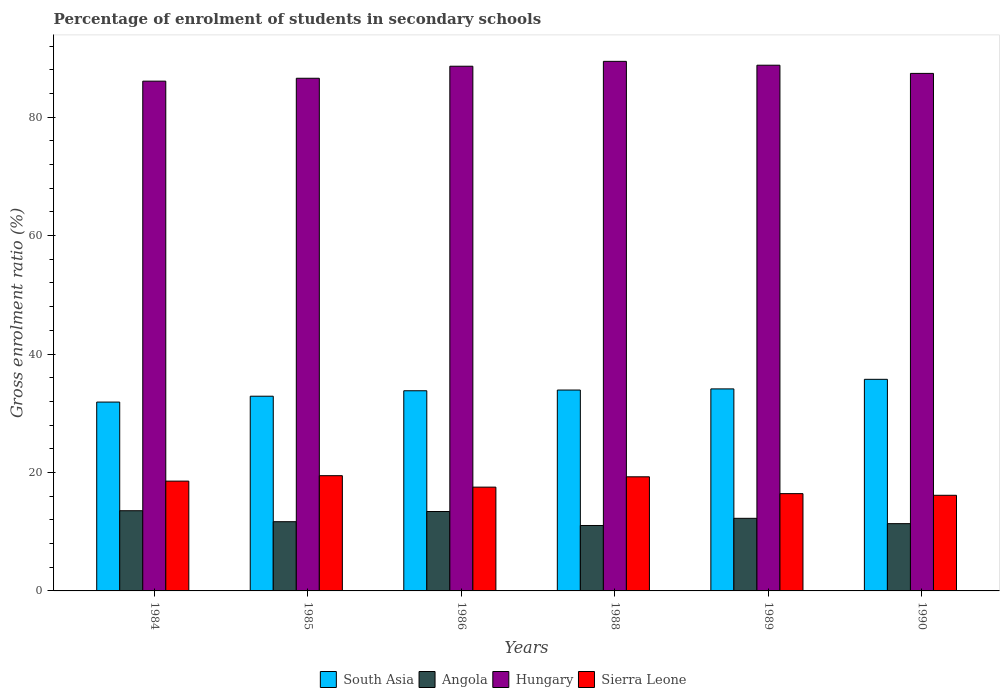How many groups of bars are there?
Your answer should be compact. 6. Are the number of bars per tick equal to the number of legend labels?
Your response must be concise. Yes. Are the number of bars on each tick of the X-axis equal?
Your response must be concise. Yes. How many bars are there on the 3rd tick from the right?
Your response must be concise. 4. What is the label of the 6th group of bars from the left?
Your response must be concise. 1990. In how many cases, is the number of bars for a given year not equal to the number of legend labels?
Offer a very short reply. 0. What is the percentage of students enrolled in secondary schools in Hungary in 1988?
Make the answer very short. 89.41. Across all years, what is the maximum percentage of students enrolled in secondary schools in Sierra Leone?
Make the answer very short. 19.46. Across all years, what is the minimum percentage of students enrolled in secondary schools in Hungary?
Provide a succinct answer. 86.07. What is the total percentage of students enrolled in secondary schools in Sierra Leone in the graph?
Your answer should be compact. 107.36. What is the difference between the percentage of students enrolled in secondary schools in South Asia in 1985 and that in 1989?
Keep it short and to the point. -1.23. What is the difference between the percentage of students enrolled in secondary schools in Sierra Leone in 1989 and the percentage of students enrolled in secondary schools in Hungary in 1990?
Make the answer very short. -70.95. What is the average percentage of students enrolled in secondary schools in Hungary per year?
Your response must be concise. 87.79. In the year 1986, what is the difference between the percentage of students enrolled in secondary schools in Sierra Leone and percentage of students enrolled in secondary schools in Hungary?
Give a very brief answer. -71.06. What is the ratio of the percentage of students enrolled in secondary schools in Hungary in 1984 to that in 1988?
Make the answer very short. 0.96. Is the difference between the percentage of students enrolled in secondary schools in Sierra Leone in 1988 and 1990 greater than the difference between the percentage of students enrolled in secondary schools in Hungary in 1988 and 1990?
Ensure brevity in your answer.  Yes. What is the difference between the highest and the second highest percentage of students enrolled in secondary schools in Hungary?
Your answer should be very brief. 0.65. What is the difference between the highest and the lowest percentage of students enrolled in secondary schools in Angola?
Offer a terse response. 2.49. In how many years, is the percentage of students enrolled in secondary schools in Angola greater than the average percentage of students enrolled in secondary schools in Angola taken over all years?
Offer a very short reply. 3. Is it the case that in every year, the sum of the percentage of students enrolled in secondary schools in Hungary and percentage of students enrolled in secondary schools in Angola is greater than the sum of percentage of students enrolled in secondary schools in Sierra Leone and percentage of students enrolled in secondary schools in South Asia?
Provide a succinct answer. No. What does the 4th bar from the left in 1986 represents?
Offer a very short reply. Sierra Leone. What does the 2nd bar from the right in 1989 represents?
Offer a very short reply. Hungary. How many years are there in the graph?
Your response must be concise. 6. Does the graph contain any zero values?
Your answer should be very brief. No. Does the graph contain grids?
Make the answer very short. No. Where does the legend appear in the graph?
Your response must be concise. Bottom center. How many legend labels are there?
Give a very brief answer. 4. What is the title of the graph?
Offer a terse response. Percentage of enrolment of students in secondary schools. Does "Timor-Leste" appear as one of the legend labels in the graph?
Keep it short and to the point. No. What is the label or title of the X-axis?
Provide a succinct answer. Years. What is the label or title of the Y-axis?
Make the answer very short. Gross enrolment ratio (%). What is the Gross enrolment ratio (%) in South Asia in 1984?
Provide a succinct answer. 31.88. What is the Gross enrolment ratio (%) of Angola in 1984?
Give a very brief answer. 13.54. What is the Gross enrolment ratio (%) of Hungary in 1984?
Provide a succinct answer. 86.07. What is the Gross enrolment ratio (%) in Sierra Leone in 1984?
Provide a succinct answer. 18.54. What is the Gross enrolment ratio (%) of South Asia in 1985?
Ensure brevity in your answer.  32.87. What is the Gross enrolment ratio (%) of Angola in 1985?
Provide a succinct answer. 11.69. What is the Gross enrolment ratio (%) in Hungary in 1985?
Offer a very short reply. 86.55. What is the Gross enrolment ratio (%) in Sierra Leone in 1985?
Keep it short and to the point. 19.46. What is the Gross enrolment ratio (%) in South Asia in 1986?
Your answer should be very brief. 33.8. What is the Gross enrolment ratio (%) in Angola in 1986?
Make the answer very short. 13.41. What is the Gross enrolment ratio (%) in Hungary in 1986?
Your response must be concise. 88.59. What is the Gross enrolment ratio (%) in Sierra Leone in 1986?
Provide a short and direct response. 17.52. What is the Gross enrolment ratio (%) of South Asia in 1988?
Your response must be concise. 33.92. What is the Gross enrolment ratio (%) in Angola in 1988?
Ensure brevity in your answer.  11.05. What is the Gross enrolment ratio (%) of Hungary in 1988?
Ensure brevity in your answer.  89.41. What is the Gross enrolment ratio (%) of Sierra Leone in 1988?
Ensure brevity in your answer.  19.27. What is the Gross enrolment ratio (%) in South Asia in 1989?
Provide a short and direct response. 34.11. What is the Gross enrolment ratio (%) of Angola in 1989?
Provide a succinct answer. 12.26. What is the Gross enrolment ratio (%) in Hungary in 1989?
Ensure brevity in your answer.  88.76. What is the Gross enrolment ratio (%) of Sierra Leone in 1989?
Give a very brief answer. 16.43. What is the Gross enrolment ratio (%) in South Asia in 1990?
Make the answer very short. 35.73. What is the Gross enrolment ratio (%) of Angola in 1990?
Your answer should be compact. 11.36. What is the Gross enrolment ratio (%) of Hungary in 1990?
Offer a very short reply. 87.38. What is the Gross enrolment ratio (%) of Sierra Leone in 1990?
Provide a succinct answer. 16.15. Across all years, what is the maximum Gross enrolment ratio (%) in South Asia?
Ensure brevity in your answer.  35.73. Across all years, what is the maximum Gross enrolment ratio (%) in Angola?
Your response must be concise. 13.54. Across all years, what is the maximum Gross enrolment ratio (%) of Hungary?
Offer a terse response. 89.41. Across all years, what is the maximum Gross enrolment ratio (%) of Sierra Leone?
Provide a succinct answer. 19.46. Across all years, what is the minimum Gross enrolment ratio (%) in South Asia?
Give a very brief answer. 31.88. Across all years, what is the minimum Gross enrolment ratio (%) of Angola?
Give a very brief answer. 11.05. Across all years, what is the minimum Gross enrolment ratio (%) of Hungary?
Provide a short and direct response. 86.07. Across all years, what is the minimum Gross enrolment ratio (%) in Sierra Leone?
Your answer should be very brief. 16.15. What is the total Gross enrolment ratio (%) of South Asia in the graph?
Keep it short and to the point. 202.31. What is the total Gross enrolment ratio (%) of Angola in the graph?
Keep it short and to the point. 73.3. What is the total Gross enrolment ratio (%) in Hungary in the graph?
Make the answer very short. 526.76. What is the total Gross enrolment ratio (%) in Sierra Leone in the graph?
Keep it short and to the point. 107.36. What is the difference between the Gross enrolment ratio (%) of South Asia in 1984 and that in 1985?
Ensure brevity in your answer.  -0.99. What is the difference between the Gross enrolment ratio (%) in Angola in 1984 and that in 1985?
Provide a succinct answer. 1.85. What is the difference between the Gross enrolment ratio (%) of Hungary in 1984 and that in 1985?
Offer a terse response. -0.49. What is the difference between the Gross enrolment ratio (%) in Sierra Leone in 1984 and that in 1985?
Your response must be concise. -0.92. What is the difference between the Gross enrolment ratio (%) in South Asia in 1984 and that in 1986?
Provide a succinct answer. -1.91. What is the difference between the Gross enrolment ratio (%) in Angola in 1984 and that in 1986?
Your response must be concise. 0.13. What is the difference between the Gross enrolment ratio (%) of Hungary in 1984 and that in 1986?
Your answer should be very brief. -2.52. What is the difference between the Gross enrolment ratio (%) of Sierra Leone in 1984 and that in 1986?
Give a very brief answer. 1.02. What is the difference between the Gross enrolment ratio (%) in South Asia in 1984 and that in 1988?
Provide a succinct answer. -2.03. What is the difference between the Gross enrolment ratio (%) of Angola in 1984 and that in 1988?
Offer a terse response. 2.49. What is the difference between the Gross enrolment ratio (%) in Hungary in 1984 and that in 1988?
Your answer should be very brief. -3.34. What is the difference between the Gross enrolment ratio (%) of Sierra Leone in 1984 and that in 1988?
Keep it short and to the point. -0.73. What is the difference between the Gross enrolment ratio (%) in South Asia in 1984 and that in 1989?
Your answer should be compact. -2.22. What is the difference between the Gross enrolment ratio (%) in Angola in 1984 and that in 1989?
Offer a very short reply. 1.28. What is the difference between the Gross enrolment ratio (%) of Hungary in 1984 and that in 1989?
Offer a terse response. -2.69. What is the difference between the Gross enrolment ratio (%) in Sierra Leone in 1984 and that in 1989?
Provide a short and direct response. 2.11. What is the difference between the Gross enrolment ratio (%) in South Asia in 1984 and that in 1990?
Give a very brief answer. -3.84. What is the difference between the Gross enrolment ratio (%) of Angola in 1984 and that in 1990?
Your answer should be compact. 2.18. What is the difference between the Gross enrolment ratio (%) of Hungary in 1984 and that in 1990?
Offer a terse response. -1.31. What is the difference between the Gross enrolment ratio (%) of Sierra Leone in 1984 and that in 1990?
Offer a terse response. 2.39. What is the difference between the Gross enrolment ratio (%) in South Asia in 1985 and that in 1986?
Offer a terse response. -0.92. What is the difference between the Gross enrolment ratio (%) of Angola in 1985 and that in 1986?
Offer a terse response. -1.72. What is the difference between the Gross enrolment ratio (%) of Hungary in 1985 and that in 1986?
Keep it short and to the point. -2.03. What is the difference between the Gross enrolment ratio (%) in Sierra Leone in 1985 and that in 1986?
Keep it short and to the point. 1.93. What is the difference between the Gross enrolment ratio (%) in South Asia in 1985 and that in 1988?
Make the answer very short. -1.04. What is the difference between the Gross enrolment ratio (%) of Angola in 1985 and that in 1988?
Your response must be concise. 0.64. What is the difference between the Gross enrolment ratio (%) in Hungary in 1985 and that in 1988?
Offer a very short reply. -2.86. What is the difference between the Gross enrolment ratio (%) of Sierra Leone in 1985 and that in 1988?
Offer a terse response. 0.19. What is the difference between the Gross enrolment ratio (%) of South Asia in 1985 and that in 1989?
Your answer should be compact. -1.23. What is the difference between the Gross enrolment ratio (%) of Angola in 1985 and that in 1989?
Provide a succinct answer. -0.57. What is the difference between the Gross enrolment ratio (%) of Hungary in 1985 and that in 1989?
Provide a succinct answer. -2.2. What is the difference between the Gross enrolment ratio (%) in Sierra Leone in 1985 and that in 1989?
Offer a very short reply. 3.03. What is the difference between the Gross enrolment ratio (%) in South Asia in 1985 and that in 1990?
Provide a short and direct response. -2.85. What is the difference between the Gross enrolment ratio (%) of Angola in 1985 and that in 1990?
Offer a very short reply. 0.33. What is the difference between the Gross enrolment ratio (%) of Hungary in 1985 and that in 1990?
Ensure brevity in your answer.  -0.82. What is the difference between the Gross enrolment ratio (%) in Sierra Leone in 1985 and that in 1990?
Give a very brief answer. 3.31. What is the difference between the Gross enrolment ratio (%) in South Asia in 1986 and that in 1988?
Your answer should be very brief. -0.12. What is the difference between the Gross enrolment ratio (%) of Angola in 1986 and that in 1988?
Give a very brief answer. 2.36. What is the difference between the Gross enrolment ratio (%) in Hungary in 1986 and that in 1988?
Give a very brief answer. -0.82. What is the difference between the Gross enrolment ratio (%) in Sierra Leone in 1986 and that in 1988?
Ensure brevity in your answer.  -1.74. What is the difference between the Gross enrolment ratio (%) of South Asia in 1986 and that in 1989?
Ensure brevity in your answer.  -0.31. What is the difference between the Gross enrolment ratio (%) in Angola in 1986 and that in 1989?
Your answer should be compact. 1.15. What is the difference between the Gross enrolment ratio (%) of Hungary in 1986 and that in 1989?
Make the answer very short. -0.17. What is the difference between the Gross enrolment ratio (%) in Sierra Leone in 1986 and that in 1989?
Offer a very short reply. 1.1. What is the difference between the Gross enrolment ratio (%) in South Asia in 1986 and that in 1990?
Give a very brief answer. -1.93. What is the difference between the Gross enrolment ratio (%) in Angola in 1986 and that in 1990?
Keep it short and to the point. 2.05. What is the difference between the Gross enrolment ratio (%) in Hungary in 1986 and that in 1990?
Your answer should be very brief. 1.21. What is the difference between the Gross enrolment ratio (%) of Sierra Leone in 1986 and that in 1990?
Provide a succinct answer. 1.38. What is the difference between the Gross enrolment ratio (%) in South Asia in 1988 and that in 1989?
Offer a very short reply. -0.19. What is the difference between the Gross enrolment ratio (%) of Angola in 1988 and that in 1989?
Provide a succinct answer. -1.21. What is the difference between the Gross enrolment ratio (%) in Hungary in 1988 and that in 1989?
Your answer should be compact. 0.65. What is the difference between the Gross enrolment ratio (%) of Sierra Leone in 1988 and that in 1989?
Give a very brief answer. 2.84. What is the difference between the Gross enrolment ratio (%) in South Asia in 1988 and that in 1990?
Give a very brief answer. -1.81. What is the difference between the Gross enrolment ratio (%) in Angola in 1988 and that in 1990?
Offer a very short reply. -0.31. What is the difference between the Gross enrolment ratio (%) of Hungary in 1988 and that in 1990?
Your answer should be very brief. 2.03. What is the difference between the Gross enrolment ratio (%) of Sierra Leone in 1988 and that in 1990?
Provide a succinct answer. 3.12. What is the difference between the Gross enrolment ratio (%) in South Asia in 1989 and that in 1990?
Offer a very short reply. -1.62. What is the difference between the Gross enrolment ratio (%) in Angola in 1989 and that in 1990?
Ensure brevity in your answer.  0.9. What is the difference between the Gross enrolment ratio (%) of Hungary in 1989 and that in 1990?
Offer a terse response. 1.38. What is the difference between the Gross enrolment ratio (%) in Sierra Leone in 1989 and that in 1990?
Your answer should be compact. 0.28. What is the difference between the Gross enrolment ratio (%) in South Asia in 1984 and the Gross enrolment ratio (%) in Angola in 1985?
Offer a terse response. 20.2. What is the difference between the Gross enrolment ratio (%) of South Asia in 1984 and the Gross enrolment ratio (%) of Hungary in 1985?
Your response must be concise. -54.67. What is the difference between the Gross enrolment ratio (%) of South Asia in 1984 and the Gross enrolment ratio (%) of Sierra Leone in 1985?
Provide a short and direct response. 12.43. What is the difference between the Gross enrolment ratio (%) in Angola in 1984 and the Gross enrolment ratio (%) in Hungary in 1985?
Keep it short and to the point. -73.02. What is the difference between the Gross enrolment ratio (%) in Angola in 1984 and the Gross enrolment ratio (%) in Sierra Leone in 1985?
Offer a terse response. -5.92. What is the difference between the Gross enrolment ratio (%) in Hungary in 1984 and the Gross enrolment ratio (%) in Sierra Leone in 1985?
Offer a terse response. 66.61. What is the difference between the Gross enrolment ratio (%) of South Asia in 1984 and the Gross enrolment ratio (%) of Angola in 1986?
Make the answer very short. 18.48. What is the difference between the Gross enrolment ratio (%) in South Asia in 1984 and the Gross enrolment ratio (%) in Hungary in 1986?
Ensure brevity in your answer.  -56.7. What is the difference between the Gross enrolment ratio (%) of South Asia in 1984 and the Gross enrolment ratio (%) of Sierra Leone in 1986?
Provide a succinct answer. 14.36. What is the difference between the Gross enrolment ratio (%) in Angola in 1984 and the Gross enrolment ratio (%) in Hungary in 1986?
Make the answer very short. -75.05. What is the difference between the Gross enrolment ratio (%) in Angola in 1984 and the Gross enrolment ratio (%) in Sierra Leone in 1986?
Your answer should be compact. -3.98. What is the difference between the Gross enrolment ratio (%) of Hungary in 1984 and the Gross enrolment ratio (%) of Sierra Leone in 1986?
Keep it short and to the point. 68.54. What is the difference between the Gross enrolment ratio (%) in South Asia in 1984 and the Gross enrolment ratio (%) in Angola in 1988?
Make the answer very short. 20.84. What is the difference between the Gross enrolment ratio (%) of South Asia in 1984 and the Gross enrolment ratio (%) of Hungary in 1988?
Your answer should be compact. -57.53. What is the difference between the Gross enrolment ratio (%) of South Asia in 1984 and the Gross enrolment ratio (%) of Sierra Leone in 1988?
Ensure brevity in your answer.  12.62. What is the difference between the Gross enrolment ratio (%) of Angola in 1984 and the Gross enrolment ratio (%) of Hungary in 1988?
Your answer should be very brief. -75.87. What is the difference between the Gross enrolment ratio (%) of Angola in 1984 and the Gross enrolment ratio (%) of Sierra Leone in 1988?
Give a very brief answer. -5.73. What is the difference between the Gross enrolment ratio (%) in Hungary in 1984 and the Gross enrolment ratio (%) in Sierra Leone in 1988?
Ensure brevity in your answer.  66.8. What is the difference between the Gross enrolment ratio (%) in South Asia in 1984 and the Gross enrolment ratio (%) in Angola in 1989?
Your answer should be very brief. 19.63. What is the difference between the Gross enrolment ratio (%) of South Asia in 1984 and the Gross enrolment ratio (%) of Hungary in 1989?
Provide a succinct answer. -56.88. What is the difference between the Gross enrolment ratio (%) in South Asia in 1984 and the Gross enrolment ratio (%) in Sierra Leone in 1989?
Give a very brief answer. 15.46. What is the difference between the Gross enrolment ratio (%) of Angola in 1984 and the Gross enrolment ratio (%) of Hungary in 1989?
Your response must be concise. -75.22. What is the difference between the Gross enrolment ratio (%) in Angola in 1984 and the Gross enrolment ratio (%) in Sierra Leone in 1989?
Provide a short and direct response. -2.89. What is the difference between the Gross enrolment ratio (%) of Hungary in 1984 and the Gross enrolment ratio (%) of Sierra Leone in 1989?
Your response must be concise. 69.64. What is the difference between the Gross enrolment ratio (%) of South Asia in 1984 and the Gross enrolment ratio (%) of Angola in 1990?
Your answer should be compact. 20.53. What is the difference between the Gross enrolment ratio (%) in South Asia in 1984 and the Gross enrolment ratio (%) in Hungary in 1990?
Make the answer very short. -55.49. What is the difference between the Gross enrolment ratio (%) of South Asia in 1984 and the Gross enrolment ratio (%) of Sierra Leone in 1990?
Ensure brevity in your answer.  15.74. What is the difference between the Gross enrolment ratio (%) of Angola in 1984 and the Gross enrolment ratio (%) of Hungary in 1990?
Your answer should be compact. -73.84. What is the difference between the Gross enrolment ratio (%) in Angola in 1984 and the Gross enrolment ratio (%) in Sierra Leone in 1990?
Give a very brief answer. -2.61. What is the difference between the Gross enrolment ratio (%) in Hungary in 1984 and the Gross enrolment ratio (%) in Sierra Leone in 1990?
Provide a succinct answer. 69.92. What is the difference between the Gross enrolment ratio (%) of South Asia in 1985 and the Gross enrolment ratio (%) of Angola in 1986?
Offer a very short reply. 19.47. What is the difference between the Gross enrolment ratio (%) of South Asia in 1985 and the Gross enrolment ratio (%) of Hungary in 1986?
Keep it short and to the point. -55.71. What is the difference between the Gross enrolment ratio (%) of South Asia in 1985 and the Gross enrolment ratio (%) of Sierra Leone in 1986?
Give a very brief answer. 15.35. What is the difference between the Gross enrolment ratio (%) of Angola in 1985 and the Gross enrolment ratio (%) of Hungary in 1986?
Provide a short and direct response. -76.9. What is the difference between the Gross enrolment ratio (%) in Angola in 1985 and the Gross enrolment ratio (%) in Sierra Leone in 1986?
Provide a short and direct response. -5.84. What is the difference between the Gross enrolment ratio (%) in Hungary in 1985 and the Gross enrolment ratio (%) in Sierra Leone in 1986?
Give a very brief answer. 69.03. What is the difference between the Gross enrolment ratio (%) of South Asia in 1985 and the Gross enrolment ratio (%) of Angola in 1988?
Ensure brevity in your answer.  21.83. What is the difference between the Gross enrolment ratio (%) in South Asia in 1985 and the Gross enrolment ratio (%) in Hungary in 1988?
Your response must be concise. -56.54. What is the difference between the Gross enrolment ratio (%) of South Asia in 1985 and the Gross enrolment ratio (%) of Sierra Leone in 1988?
Keep it short and to the point. 13.61. What is the difference between the Gross enrolment ratio (%) in Angola in 1985 and the Gross enrolment ratio (%) in Hungary in 1988?
Keep it short and to the point. -77.72. What is the difference between the Gross enrolment ratio (%) in Angola in 1985 and the Gross enrolment ratio (%) in Sierra Leone in 1988?
Your answer should be very brief. -7.58. What is the difference between the Gross enrolment ratio (%) of Hungary in 1985 and the Gross enrolment ratio (%) of Sierra Leone in 1988?
Offer a very short reply. 67.29. What is the difference between the Gross enrolment ratio (%) in South Asia in 1985 and the Gross enrolment ratio (%) in Angola in 1989?
Provide a short and direct response. 20.62. What is the difference between the Gross enrolment ratio (%) of South Asia in 1985 and the Gross enrolment ratio (%) of Hungary in 1989?
Keep it short and to the point. -55.88. What is the difference between the Gross enrolment ratio (%) of South Asia in 1985 and the Gross enrolment ratio (%) of Sierra Leone in 1989?
Make the answer very short. 16.45. What is the difference between the Gross enrolment ratio (%) of Angola in 1985 and the Gross enrolment ratio (%) of Hungary in 1989?
Keep it short and to the point. -77.07. What is the difference between the Gross enrolment ratio (%) of Angola in 1985 and the Gross enrolment ratio (%) of Sierra Leone in 1989?
Ensure brevity in your answer.  -4.74. What is the difference between the Gross enrolment ratio (%) in Hungary in 1985 and the Gross enrolment ratio (%) in Sierra Leone in 1989?
Make the answer very short. 70.13. What is the difference between the Gross enrolment ratio (%) in South Asia in 1985 and the Gross enrolment ratio (%) in Angola in 1990?
Give a very brief answer. 21.52. What is the difference between the Gross enrolment ratio (%) of South Asia in 1985 and the Gross enrolment ratio (%) of Hungary in 1990?
Your response must be concise. -54.5. What is the difference between the Gross enrolment ratio (%) of South Asia in 1985 and the Gross enrolment ratio (%) of Sierra Leone in 1990?
Keep it short and to the point. 16.73. What is the difference between the Gross enrolment ratio (%) of Angola in 1985 and the Gross enrolment ratio (%) of Hungary in 1990?
Ensure brevity in your answer.  -75.69. What is the difference between the Gross enrolment ratio (%) of Angola in 1985 and the Gross enrolment ratio (%) of Sierra Leone in 1990?
Keep it short and to the point. -4.46. What is the difference between the Gross enrolment ratio (%) of Hungary in 1985 and the Gross enrolment ratio (%) of Sierra Leone in 1990?
Keep it short and to the point. 70.41. What is the difference between the Gross enrolment ratio (%) of South Asia in 1986 and the Gross enrolment ratio (%) of Angola in 1988?
Provide a succinct answer. 22.75. What is the difference between the Gross enrolment ratio (%) of South Asia in 1986 and the Gross enrolment ratio (%) of Hungary in 1988?
Provide a succinct answer. -55.61. What is the difference between the Gross enrolment ratio (%) of South Asia in 1986 and the Gross enrolment ratio (%) of Sierra Leone in 1988?
Your answer should be compact. 14.53. What is the difference between the Gross enrolment ratio (%) in Angola in 1986 and the Gross enrolment ratio (%) in Hungary in 1988?
Make the answer very short. -76. What is the difference between the Gross enrolment ratio (%) of Angola in 1986 and the Gross enrolment ratio (%) of Sierra Leone in 1988?
Make the answer very short. -5.86. What is the difference between the Gross enrolment ratio (%) of Hungary in 1986 and the Gross enrolment ratio (%) of Sierra Leone in 1988?
Ensure brevity in your answer.  69.32. What is the difference between the Gross enrolment ratio (%) of South Asia in 1986 and the Gross enrolment ratio (%) of Angola in 1989?
Provide a succinct answer. 21.54. What is the difference between the Gross enrolment ratio (%) of South Asia in 1986 and the Gross enrolment ratio (%) of Hungary in 1989?
Ensure brevity in your answer.  -54.96. What is the difference between the Gross enrolment ratio (%) of South Asia in 1986 and the Gross enrolment ratio (%) of Sierra Leone in 1989?
Provide a succinct answer. 17.37. What is the difference between the Gross enrolment ratio (%) in Angola in 1986 and the Gross enrolment ratio (%) in Hungary in 1989?
Offer a terse response. -75.35. What is the difference between the Gross enrolment ratio (%) in Angola in 1986 and the Gross enrolment ratio (%) in Sierra Leone in 1989?
Your answer should be compact. -3.02. What is the difference between the Gross enrolment ratio (%) in Hungary in 1986 and the Gross enrolment ratio (%) in Sierra Leone in 1989?
Give a very brief answer. 72.16. What is the difference between the Gross enrolment ratio (%) in South Asia in 1986 and the Gross enrolment ratio (%) in Angola in 1990?
Offer a very short reply. 22.44. What is the difference between the Gross enrolment ratio (%) of South Asia in 1986 and the Gross enrolment ratio (%) of Hungary in 1990?
Your answer should be very brief. -53.58. What is the difference between the Gross enrolment ratio (%) of South Asia in 1986 and the Gross enrolment ratio (%) of Sierra Leone in 1990?
Your response must be concise. 17.65. What is the difference between the Gross enrolment ratio (%) in Angola in 1986 and the Gross enrolment ratio (%) in Hungary in 1990?
Offer a very short reply. -73.97. What is the difference between the Gross enrolment ratio (%) of Angola in 1986 and the Gross enrolment ratio (%) of Sierra Leone in 1990?
Provide a succinct answer. -2.74. What is the difference between the Gross enrolment ratio (%) of Hungary in 1986 and the Gross enrolment ratio (%) of Sierra Leone in 1990?
Keep it short and to the point. 72.44. What is the difference between the Gross enrolment ratio (%) in South Asia in 1988 and the Gross enrolment ratio (%) in Angola in 1989?
Ensure brevity in your answer.  21.66. What is the difference between the Gross enrolment ratio (%) of South Asia in 1988 and the Gross enrolment ratio (%) of Hungary in 1989?
Give a very brief answer. -54.84. What is the difference between the Gross enrolment ratio (%) in South Asia in 1988 and the Gross enrolment ratio (%) in Sierra Leone in 1989?
Offer a very short reply. 17.49. What is the difference between the Gross enrolment ratio (%) of Angola in 1988 and the Gross enrolment ratio (%) of Hungary in 1989?
Offer a very short reply. -77.71. What is the difference between the Gross enrolment ratio (%) in Angola in 1988 and the Gross enrolment ratio (%) in Sierra Leone in 1989?
Provide a short and direct response. -5.38. What is the difference between the Gross enrolment ratio (%) of Hungary in 1988 and the Gross enrolment ratio (%) of Sierra Leone in 1989?
Your response must be concise. 72.98. What is the difference between the Gross enrolment ratio (%) of South Asia in 1988 and the Gross enrolment ratio (%) of Angola in 1990?
Provide a short and direct response. 22.56. What is the difference between the Gross enrolment ratio (%) in South Asia in 1988 and the Gross enrolment ratio (%) in Hungary in 1990?
Ensure brevity in your answer.  -53.46. What is the difference between the Gross enrolment ratio (%) of South Asia in 1988 and the Gross enrolment ratio (%) of Sierra Leone in 1990?
Your answer should be very brief. 17.77. What is the difference between the Gross enrolment ratio (%) in Angola in 1988 and the Gross enrolment ratio (%) in Hungary in 1990?
Your answer should be compact. -76.33. What is the difference between the Gross enrolment ratio (%) of Angola in 1988 and the Gross enrolment ratio (%) of Sierra Leone in 1990?
Keep it short and to the point. -5.1. What is the difference between the Gross enrolment ratio (%) of Hungary in 1988 and the Gross enrolment ratio (%) of Sierra Leone in 1990?
Your answer should be very brief. 73.26. What is the difference between the Gross enrolment ratio (%) in South Asia in 1989 and the Gross enrolment ratio (%) in Angola in 1990?
Your response must be concise. 22.75. What is the difference between the Gross enrolment ratio (%) in South Asia in 1989 and the Gross enrolment ratio (%) in Hungary in 1990?
Your response must be concise. -53.27. What is the difference between the Gross enrolment ratio (%) in South Asia in 1989 and the Gross enrolment ratio (%) in Sierra Leone in 1990?
Make the answer very short. 17.96. What is the difference between the Gross enrolment ratio (%) of Angola in 1989 and the Gross enrolment ratio (%) of Hungary in 1990?
Your answer should be compact. -75.12. What is the difference between the Gross enrolment ratio (%) of Angola in 1989 and the Gross enrolment ratio (%) of Sierra Leone in 1990?
Provide a succinct answer. -3.89. What is the difference between the Gross enrolment ratio (%) of Hungary in 1989 and the Gross enrolment ratio (%) of Sierra Leone in 1990?
Your response must be concise. 72.61. What is the average Gross enrolment ratio (%) of South Asia per year?
Provide a short and direct response. 33.72. What is the average Gross enrolment ratio (%) in Angola per year?
Ensure brevity in your answer.  12.22. What is the average Gross enrolment ratio (%) of Hungary per year?
Keep it short and to the point. 87.79. What is the average Gross enrolment ratio (%) in Sierra Leone per year?
Your response must be concise. 17.89. In the year 1984, what is the difference between the Gross enrolment ratio (%) of South Asia and Gross enrolment ratio (%) of Angola?
Offer a very short reply. 18.34. In the year 1984, what is the difference between the Gross enrolment ratio (%) in South Asia and Gross enrolment ratio (%) in Hungary?
Give a very brief answer. -54.18. In the year 1984, what is the difference between the Gross enrolment ratio (%) in South Asia and Gross enrolment ratio (%) in Sierra Leone?
Offer a terse response. 13.34. In the year 1984, what is the difference between the Gross enrolment ratio (%) of Angola and Gross enrolment ratio (%) of Hungary?
Provide a succinct answer. -72.53. In the year 1984, what is the difference between the Gross enrolment ratio (%) of Angola and Gross enrolment ratio (%) of Sierra Leone?
Give a very brief answer. -5. In the year 1984, what is the difference between the Gross enrolment ratio (%) in Hungary and Gross enrolment ratio (%) in Sierra Leone?
Keep it short and to the point. 67.53. In the year 1985, what is the difference between the Gross enrolment ratio (%) in South Asia and Gross enrolment ratio (%) in Angola?
Provide a succinct answer. 21.19. In the year 1985, what is the difference between the Gross enrolment ratio (%) of South Asia and Gross enrolment ratio (%) of Hungary?
Provide a succinct answer. -53.68. In the year 1985, what is the difference between the Gross enrolment ratio (%) in South Asia and Gross enrolment ratio (%) in Sierra Leone?
Your response must be concise. 13.42. In the year 1985, what is the difference between the Gross enrolment ratio (%) of Angola and Gross enrolment ratio (%) of Hungary?
Your answer should be compact. -74.87. In the year 1985, what is the difference between the Gross enrolment ratio (%) in Angola and Gross enrolment ratio (%) in Sierra Leone?
Offer a terse response. -7.77. In the year 1985, what is the difference between the Gross enrolment ratio (%) of Hungary and Gross enrolment ratio (%) of Sierra Leone?
Give a very brief answer. 67.1. In the year 1986, what is the difference between the Gross enrolment ratio (%) of South Asia and Gross enrolment ratio (%) of Angola?
Keep it short and to the point. 20.39. In the year 1986, what is the difference between the Gross enrolment ratio (%) of South Asia and Gross enrolment ratio (%) of Hungary?
Your response must be concise. -54.79. In the year 1986, what is the difference between the Gross enrolment ratio (%) in South Asia and Gross enrolment ratio (%) in Sierra Leone?
Your answer should be very brief. 16.27. In the year 1986, what is the difference between the Gross enrolment ratio (%) of Angola and Gross enrolment ratio (%) of Hungary?
Offer a very short reply. -75.18. In the year 1986, what is the difference between the Gross enrolment ratio (%) in Angola and Gross enrolment ratio (%) in Sierra Leone?
Offer a terse response. -4.11. In the year 1986, what is the difference between the Gross enrolment ratio (%) in Hungary and Gross enrolment ratio (%) in Sierra Leone?
Your answer should be very brief. 71.06. In the year 1988, what is the difference between the Gross enrolment ratio (%) of South Asia and Gross enrolment ratio (%) of Angola?
Make the answer very short. 22.87. In the year 1988, what is the difference between the Gross enrolment ratio (%) in South Asia and Gross enrolment ratio (%) in Hungary?
Keep it short and to the point. -55.49. In the year 1988, what is the difference between the Gross enrolment ratio (%) of South Asia and Gross enrolment ratio (%) of Sierra Leone?
Provide a short and direct response. 14.65. In the year 1988, what is the difference between the Gross enrolment ratio (%) of Angola and Gross enrolment ratio (%) of Hungary?
Make the answer very short. -78.36. In the year 1988, what is the difference between the Gross enrolment ratio (%) of Angola and Gross enrolment ratio (%) of Sierra Leone?
Offer a terse response. -8.22. In the year 1988, what is the difference between the Gross enrolment ratio (%) in Hungary and Gross enrolment ratio (%) in Sierra Leone?
Ensure brevity in your answer.  70.14. In the year 1989, what is the difference between the Gross enrolment ratio (%) in South Asia and Gross enrolment ratio (%) in Angola?
Offer a terse response. 21.85. In the year 1989, what is the difference between the Gross enrolment ratio (%) in South Asia and Gross enrolment ratio (%) in Hungary?
Your response must be concise. -54.65. In the year 1989, what is the difference between the Gross enrolment ratio (%) in South Asia and Gross enrolment ratio (%) in Sierra Leone?
Give a very brief answer. 17.68. In the year 1989, what is the difference between the Gross enrolment ratio (%) of Angola and Gross enrolment ratio (%) of Hungary?
Give a very brief answer. -76.5. In the year 1989, what is the difference between the Gross enrolment ratio (%) in Angola and Gross enrolment ratio (%) in Sierra Leone?
Give a very brief answer. -4.17. In the year 1989, what is the difference between the Gross enrolment ratio (%) in Hungary and Gross enrolment ratio (%) in Sierra Leone?
Ensure brevity in your answer.  72.33. In the year 1990, what is the difference between the Gross enrolment ratio (%) in South Asia and Gross enrolment ratio (%) in Angola?
Give a very brief answer. 24.37. In the year 1990, what is the difference between the Gross enrolment ratio (%) in South Asia and Gross enrolment ratio (%) in Hungary?
Ensure brevity in your answer.  -51.65. In the year 1990, what is the difference between the Gross enrolment ratio (%) in South Asia and Gross enrolment ratio (%) in Sierra Leone?
Ensure brevity in your answer.  19.58. In the year 1990, what is the difference between the Gross enrolment ratio (%) of Angola and Gross enrolment ratio (%) of Hungary?
Give a very brief answer. -76.02. In the year 1990, what is the difference between the Gross enrolment ratio (%) in Angola and Gross enrolment ratio (%) in Sierra Leone?
Offer a terse response. -4.79. In the year 1990, what is the difference between the Gross enrolment ratio (%) in Hungary and Gross enrolment ratio (%) in Sierra Leone?
Keep it short and to the point. 71.23. What is the ratio of the Gross enrolment ratio (%) of South Asia in 1984 to that in 1985?
Your response must be concise. 0.97. What is the ratio of the Gross enrolment ratio (%) of Angola in 1984 to that in 1985?
Keep it short and to the point. 1.16. What is the ratio of the Gross enrolment ratio (%) of Hungary in 1984 to that in 1985?
Your response must be concise. 0.99. What is the ratio of the Gross enrolment ratio (%) of Sierra Leone in 1984 to that in 1985?
Offer a terse response. 0.95. What is the ratio of the Gross enrolment ratio (%) of South Asia in 1984 to that in 1986?
Your answer should be compact. 0.94. What is the ratio of the Gross enrolment ratio (%) of Angola in 1984 to that in 1986?
Provide a succinct answer. 1.01. What is the ratio of the Gross enrolment ratio (%) of Hungary in 1984 to that in 1986?
Your response must be concise. 0.97. What is the ratio of the Gross enrolment ratio (%) of Sierra Leone in 1984 to that in 1986?
Your answer should be compact. 1.06. What is the ratio of the Gross enrolment ratio (%) in South Asia in 1984 to that in 1988?
Your answer should be compact. 0.94. What is the ratio of the Gross enrolment ratio (%) in Angola in 1984 to that in 1988?
Keep it short and to the point. 1.23. What is the ratio of the Gross enrolment ratio (%) in Hungary in 1984 to that in 1988?
Give a very brief answer. 0.96. What is the ratio of the Gross enrolment ratio (%) in Sierra Leone in 1984 to that in 1988?
Provide a short and direct response. 0.96. What is the ratio of the Gross enrolment ratio (%) in South Asia in 1984 to that in 1989?
Make the answer very short. 0.93. What is the ratio of the Gross enrolment ratio (%) in Angola in 1984 to that in 1989?
Your answer should be compact. 1.1. What is the ratio of the Gross enrolment ratio (%) in Hungary in 1984 to that in 1989?
Keep it short and to the point. 0.97. What is the ratio of the Gross enrolment ratio (%) in Sierra Leone in 1984 to that in 1989?
Provide a succinct answer. 1.13. What is the ratio of the Gross enrolment ratio (%) of South Asia in 1984 to that in 1990?
Offer a terse response. 0.89. What is the ratio of the Gross enrolment ratio (%) in Angola in 1984 to that in 1990?
Your answer should be very brief. 1.19. What is the ratio of the Gross enrolment ratio (%) in Hungary in 1984 to that in 1990?
Ensure brevity in your answer.  0.98. What is the ratio of the Gross enrolment ratio (%) in Sierra Leone in 1984 to that in 1990?
Your answer should be compact. 1.15. What is the ratio of the Gross enrolment ratio (%) in South Asia in 1985 to that in 1986?
Make the answer very short. 0.97. What is the ratio of the Gross enrolment ratio (%) in Angola in 1985 to that in 1986?
Provide a succinct answer. 0.87. What is the ratio of the Gross enrolment ratio (%) of Hungary in 1985 to that in 1986?
Offer a terse response. 0.98. What is the ratio of the Gross enrolment ratio (%) of Sierra Leone in 1985 to that in 1986?
Offer a terse response. 1.11. What is the ratio of the Gross enrolment ratio (%) in South Asia in 1985 to that in 1988?
Make the answer very short. 0.97. What is the ratio of the Gross enrolment ratio (%) in Angola in 1985 to that in 1988?
Ensure brevity in your answer.  1.06. What is the ratio of the Gross enrolment ratio (%) in Hungary in 1985 to that in 1988?
Keep it short and to the point. 0.97. What is the ratio of the Gross enrolment ratio (%) in Sierra Leone in 1985 to that in 1988?
Make the answer very short. 1.01. What is the ratio of the Gross enrolment ratio (%) in South Asia in 1985 to that in 1989?
Your response must be concise. 0.96. What is the ratio of the Gross enrolment ratio (%) in Angola in 1985 to that in 1989?
Ensure brevity in your answer.  0.95. What is the ratio of the Gross enrolment ratio (%) in Hungary in 1985 to that in 1989?
Make the answer very short. 0.98. What is the ratio of the Gross enrolment ratio (%) of Sierra Leone in 1985 to that in 1989?
Provide a short and direct response. 1.18. What is the ratio of the Gross enrolment ratio (%) of South Asia in 1985 to that in 1990?
Offer a terse response. 0.92. What is the ratio of the Gross enrolment ratio (%) of Angola in 1985 to that in 1990?
Provide a succinct answer. 1.03. What is the ratio of the Gross enrolment ratio (%) of Hungary in 1985 to that in 1990?
Give a very brief answer. 0.99. What is the ratio of the Gross enrolment ratio (%) in Sierra Leone in 1985 to that in 1990?
Give a very brief answer. 1.2. What is the ratio of the Gross enrolment ratio (%) in Angola in 1986 to that in 1988?
Ensure brevity in your answer.  1.21. What is the ratio of the Gross enrolment ratio (%) in Hungary in 1986 to that in 1988?
Offer a terse response. 0.99. What is the ratio of the Gross enrolment ratio (%) in Sierra Leone in 1986 to that in 1988?
Keep it short and to the point. 0.91. What is the ratio of the Gross enrolment ratio (%) of South Asia in 1986 to that in 1989?
Make the answer very short. 0.99. What is the ratio of the Gross enrolment ratio (%) of Angola in 1986 to that in 1989?
Give a very brief answer. 1.09. What is the ratio of the Gross enrolment ratio (%) in Sierra Leone in 1986 to that in 1989?
Keep it short and to the point. 1.07. What is the ratio of the Gross enrolment ratio (%) of South Asia in 1986 to that in 1990?
Your response must be concise. 0.95. What is the ratio of the Gross enrolment ratio (%) in Angola in 1986 to that in 1990?
Keep it short and to the point. 1.18. What is the ratio of the Gross enrolment ratio (%) of Hungary in 1986 to that in 1990?
Provide a short and direct response. 1.01. What is the ratio of the Gross enrolment ratio (%) of Sierra Leone in 1986 to that in 1990?
Make the answer very short. 1.09. What is the ratio of the Gross enrolment ratio (%) in Angola in 1988 to that in 1989?
Offer a terse response. 0.9. What is the ratio of the Gross enrolment ratio (%) in Hungary in 1988 to that in 1989?
Your response must be concise. 1.01. What is the ratio of the Gross enrolment ratio (%) in Sierra Leone in 1988 to that in 1989?
Your response must be concise. 1.17. What is the ratio of the Gross enrolment ratio (%) of South Asia in 1988 to that in 1990?
Give a very brief answer. 0.95. What is the ratio of the Gross enrolment ratio (%) of Angola in 1988 to that in 1990?
Ensure brevity in your answer.  0.97. What is the ratio of the Gross enrolment ratio (%) in Hungary in 1988 to that in 1990?
Offer a very short reply. 1.02. What is the ratio of the Gross enrolment ratio (%) in Sierra Leone in 1988 to that in 1990?
Your answer should be compact. 1.19. What is the ratio of the Gross enrolment ratio (%) in South Asia in 1989 to that in 1990?
Ensure brevity in your answer.  0.95. What is the ratio of the Gross enrolment ratio (%) of Angola in 1989 to that in 1990?
Provide a succinct answer. 1.08. What is the ratio of the Gross enrolment ratio (%) of Hungary in 1989 to that in 1990?
Keep it short and to the point. 1.02. What is the ratio of the Gross enrolment ratio (%) in Sierra Leone in 1989 to that in 1990?
Offer a very short reply. 1.02. What is the difference between the highest and the second highest Gross enrolment ratio (%) in South Asia?
Offer a very short reply. 1.62. What is the difference between the highest and the second highest Gross enrolment ratio (%) in Angola?
Provide a succinct answer. 0.13. What is the difference between the highest and the second highest Gross enrolment ratio (%) of Hungary?
Provide a succinct answer. 0.65. What is the difference between the highest and the second highest Gross enrolment ratio (%) in Sierra Leone?
Ensure brevity in your answer.  0.19. What is the difference between the highest and the lowest Gross enrolment ratio (%) of South Asia?
Give a very brief answer. 3.84. What is the difference between the highest and the lowest Gross enrolment ratio (%) in Angola?
Make the answer very short. 2.49. What is the difference between the highest and the lowest Gross enrolment ratio (%) in Hungary?
Your answer should be very brief. 3.34. What is the difference between the highest and the lowest Gross enrolment ratio (%) of Sierra Leone?
Keep it short and to the point. 3.31. 